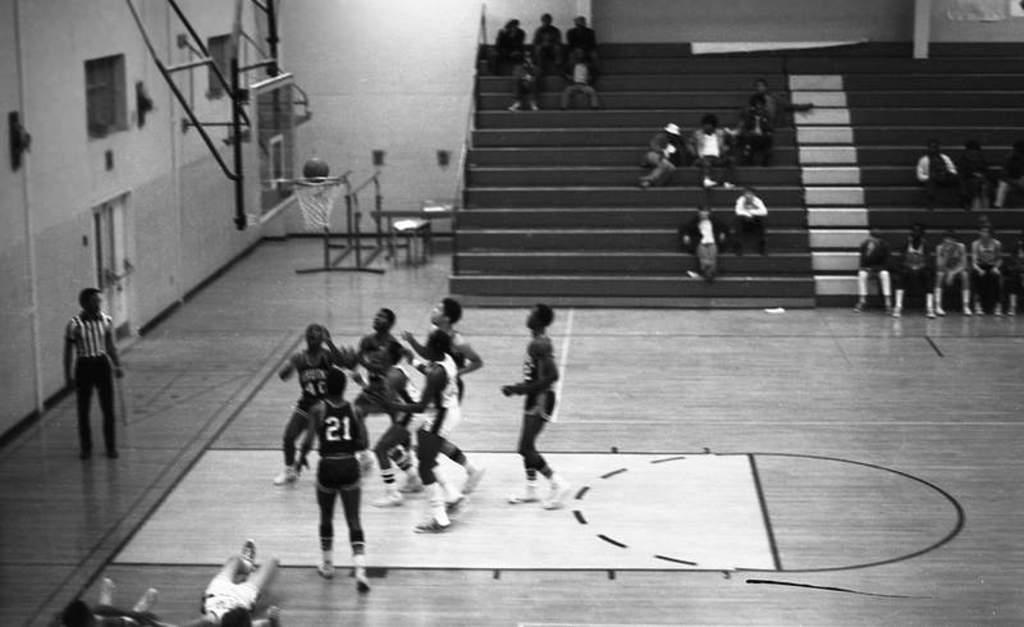What is the number on the jersey?
Your response must be concise. 21. 